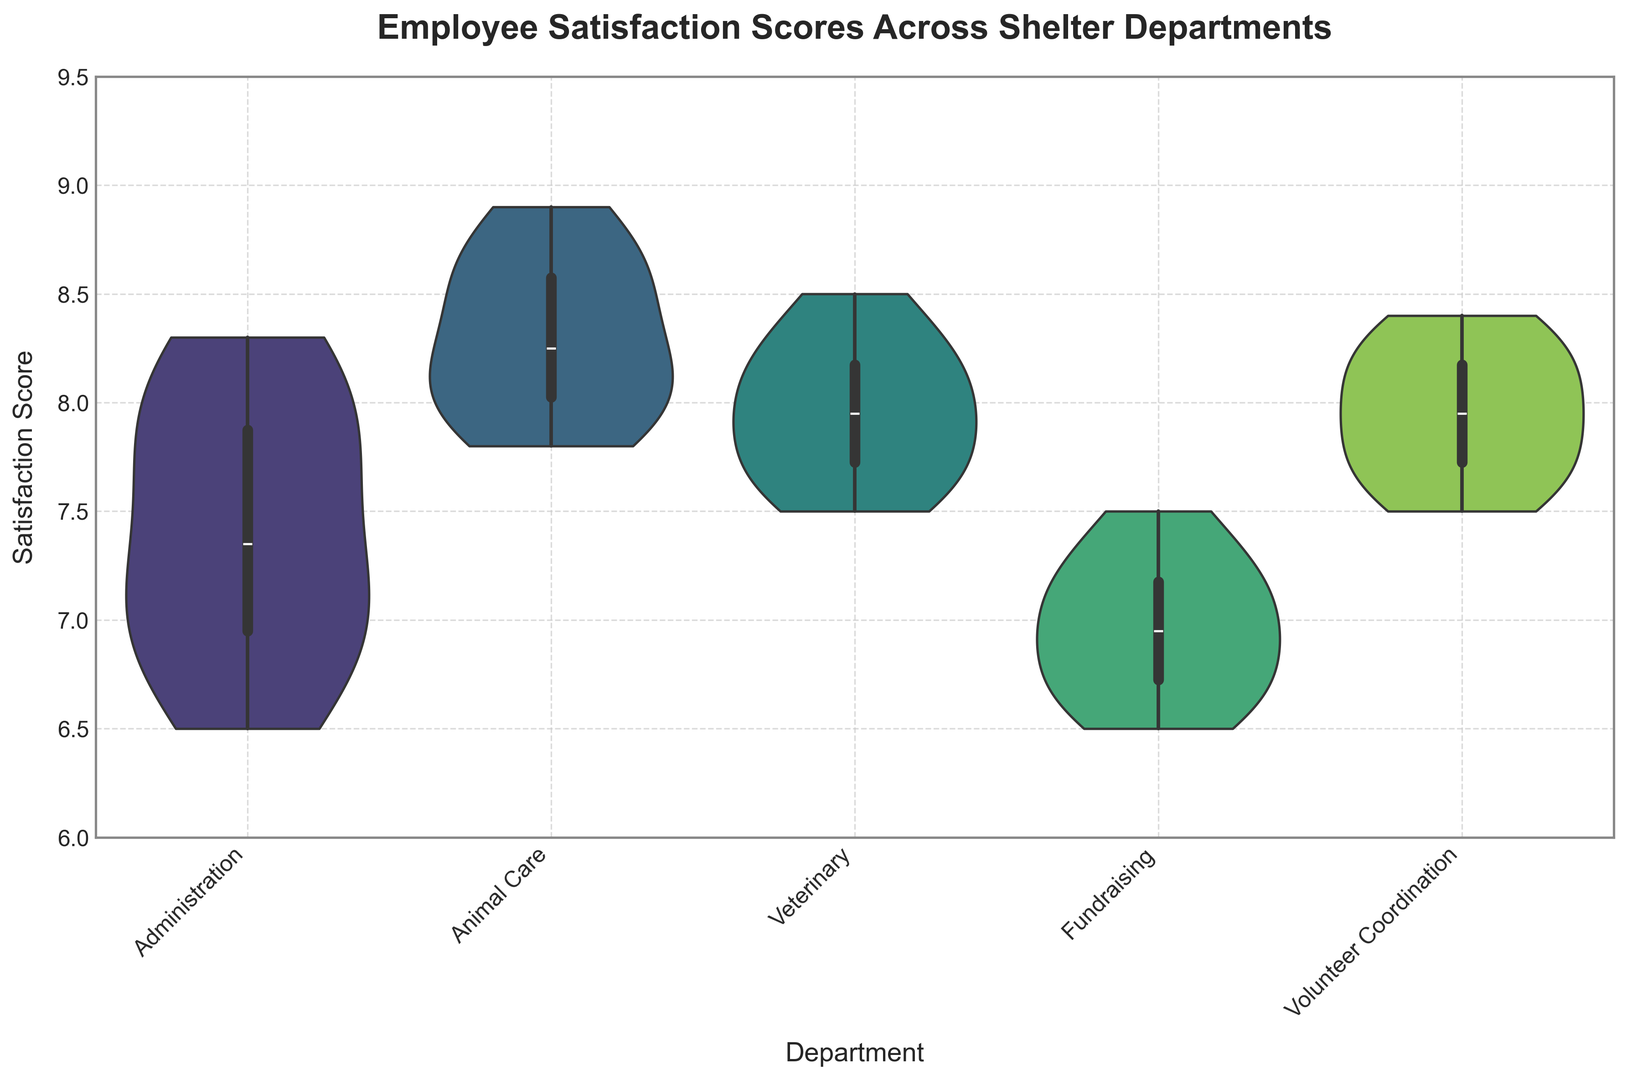What department has the highest median satisfaction score? The median satisfaction score can be visually determined by the thick horizontal line within each violin. The median for Animal Care appears to be the highest.
Answer: Animal Care Which department has the widest range of satisfaction scores? The range can be determined by looking at the height of the violin plot for each department. Administration has the widest range.
Answer: Administration What's the difference between the highest satisfaction score in Fundraising and Veterinary? Fundraising has a maximum score around 7.5, and Veterinary has a maximum score around 8.5. The difference is 8.5 - 7.5 = 1.
Answer: 1 How does the median satisfaction score of Volunteer Coordination compare to that of Administration? By comparing the thick horizontal lines (medians) of each, we can see that Volunteer Coordination has a higher median than Administration.
Answer: Volunteer Coordination > Administration What is the interquartile range (IQR) of satisfaction scores in the Animal Care department? The IQR can be determined by the width of the violin plot (spanning from the 25th to the 75th percentile). For Animal Care, this range goes approximately from 7.8 to 8.6, so 8.6 - 7.8 = 0.8.
Answer: 0.8 Among Administration, Volunteer Coordination, and Veterinary, which department has the lowest satisfaction scores? By comparing the lower edges of the violin plots, Administration has the lowest minimum score around 6.5.
Answer: Administration Which department has the most concentrated satisfaction scores around the median? This can be identified by assessing the density of the area around the median. Veterinary shows a high concentration of scores around its median.
Answer: Veterinary What percentage of Animal Care's satisfaction scores appear to be above 8? Visually estimate the proportion of the area of the violin plot above the score of 8. It appears to be roughly around 70%.
Answer: Approximately 70% Compare the spread of satisfaction scores in Fundraising and Volunteer Coordination. Fundraising's spread is more narrow and concentrated around 6.5 to 7.5, while Volunteer Coordination has a wider distribution from about 7.5 to 8.5.
Answer: Fundraising < Volunteer Coordination 